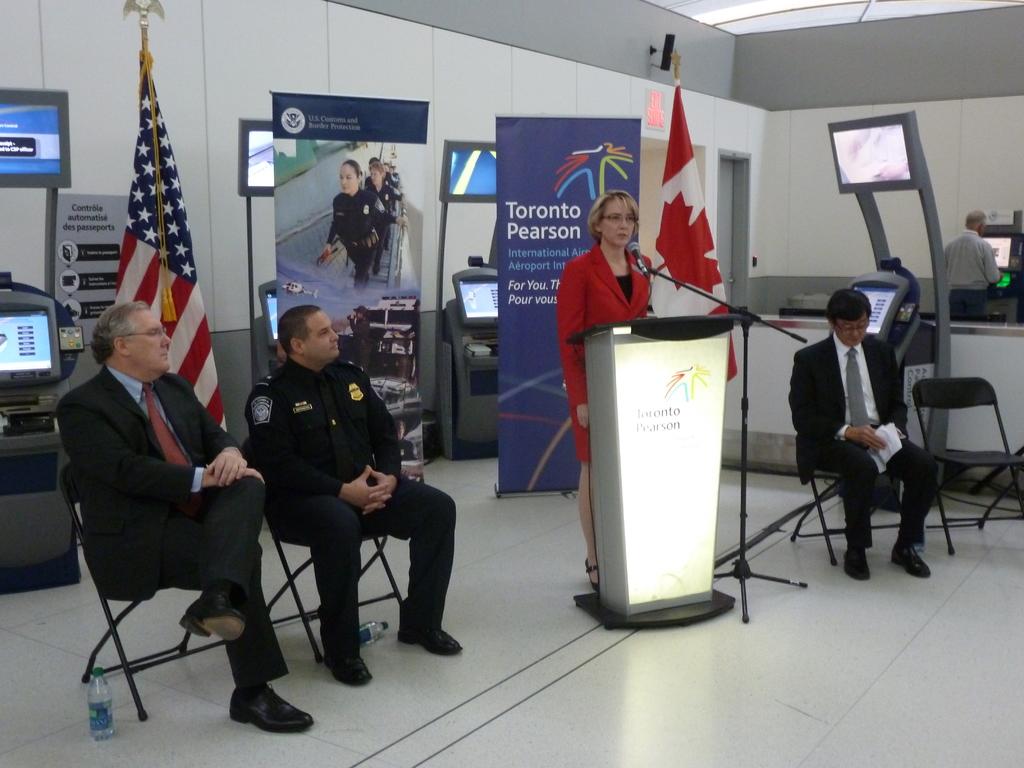What airport does this take place in?
Offer a very short reply. Toronto pearson. A canadian airport?
Offer a very short reply. Yes. 